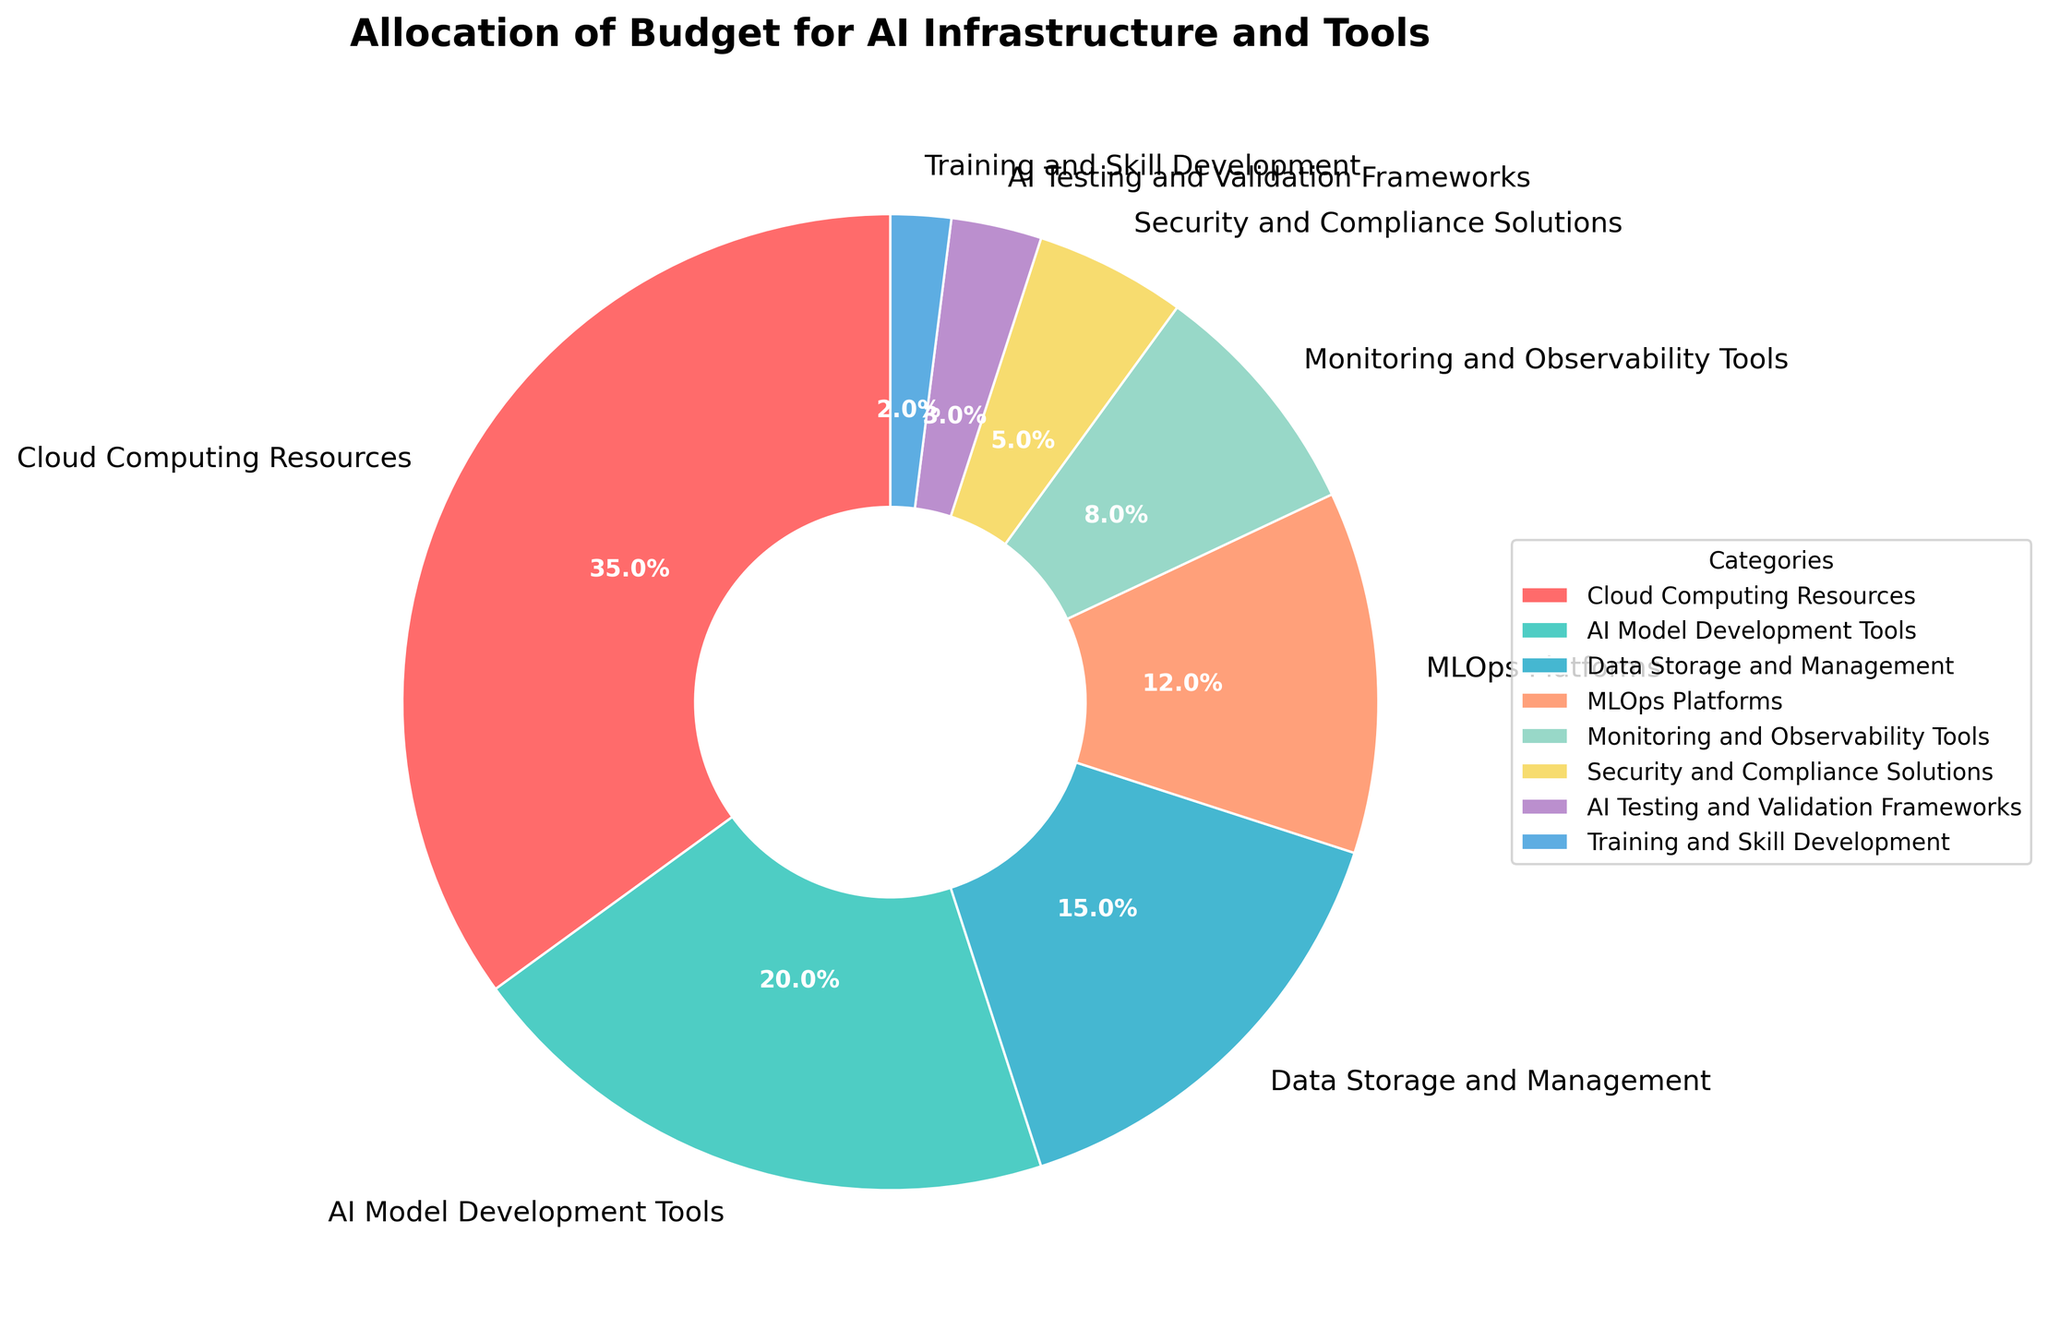What percentage of the budget is allocated to Cloud Computing Resources? Cloud Computing Resources hold a single slice of the pie chart labeled as 35%.
Answer: 35% What is the smallest budget allocation category and its percentage? The smallest slice of the pie chart is for Training and Skill Development, which is labeled as 2%.
Answer: Training and Skill Development, 2% How much more budget is allocated to AI Model Development Tools compared to Data Storage and Management? AI Model Development Tools have a budget of 20%, and Data Storage and Management have 15%. The difference is calculated as 20% - 15% = 5%.
Answer: 5% Which category is allocated the second highest percentage of the budget and what is this percentage? The second largest slice of the pie chart is for AI Model Development Tools, which has a percentage of 20%.
Answer: AI Model Development Tools, 20% How many categories receive more than 10% of the budget? The pie chart shows that Cloud Computing Resources (35%), AI Model Development Tools (20%), Data Storage and Management (15%), and MLOps Platforms (12%) each receive more than 10% of the budget. This totals to 4 categories.
Answer: 4 Which category has a higher budget allocation: Monitoring and Observability Tools or AI Testing and Validation Frameworks, and by how much? Monitoring and Observability Tools have a budget allocation of 8%, while AI Testing and Validation Frameworks have 3%. The difference is 8% - 3% = 5%.
Answer: Monitoring and Observability Tools by 5% What is the total percentage of budget allocation for Security and Compliance Solutions and Training and Skill Development combined? The percentages for Security and Compliance Solutions and Training and Skill Development are 5% and 2%, respectively. Adding them gives 5% + 2% = 7%.
Answer: 7% Which category is shown in green on the pie chart and what is its percentage? The green slice represents AI Model Development Tools, which is labeled as 20%.
Answer: AI Model Development Tools, 20% Rank the categories from highest to lowest percentage allocation. The pie chart can be ranked from highest to lowest as follows: Cloud Computing Resources (35%), AI Model Development Tools (20%), Data Storage and Management (15%), MLOps Platforms (12%), Monitoring and Observability Tools (8%), Security and Compliance Solutions (5%), AI Testing and Validation Frameworks (3%), Training and Skill Development (2%).
Answer: Cloud Computing Resources, AI Model Development Tools, Data Storage and Management, MLOps Platforms, Monitoring and Observability Tools, Security and Compliance Solutions, AI Testing and Validation Frameworks, Training and Skill Development 